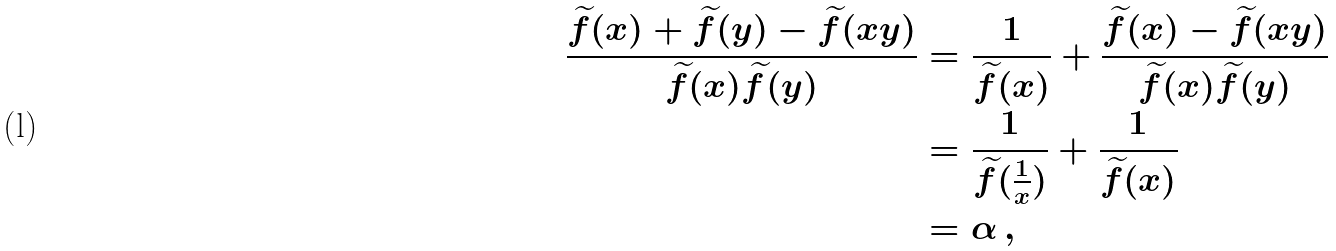Convert formula to latex. <formula><loc_0><loc_0><loc_500><loc_500>\frac { \widetilde { f } ( x ) + \widetilde { f } ( y ) - \widetilde { f } ( x y ) } { \widetilde { f } ( x ) \widetilde { f } ( y ) } & = \frac { 1 } { \widetilde { f } ( x ) } + \frac { \widetilde { f } ( x ) - \widetilde { f } ( x y ) } { \widetilde { f } ( x ) \widetilde { f } ( y ) } \\ & = \frac { 1 } { \widetilde { f } ( \frac { 1 } { x } ) } + \frac { 1 } { \widetilde { f } ( x ) } \\ & = \alpha \, ,</formula> 